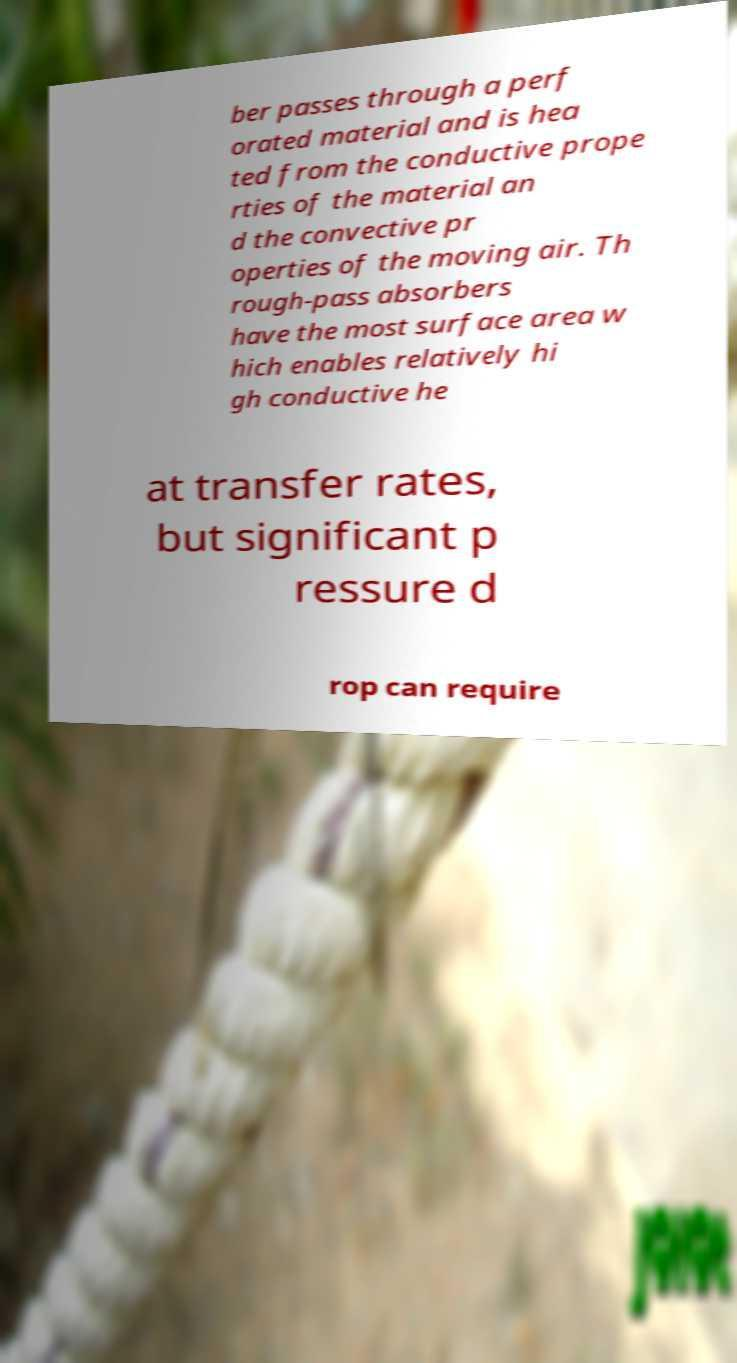Please read and relay the text visible in this image. What does it say? ber passes through a perf orated material and is hea ted from the conductive prope rties of the material an d the convective pr operties of the moving air. Th rough-pass absorbers have the most surface area w hich enables relatively hi gh conductive he at transfer rates, but significant p ressure d rop can require 